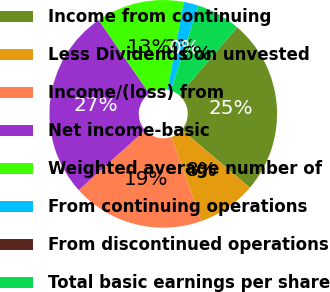Convert chart. <chart><loc_0><loc_0><loc_500><loc_500><pie_chart><fcel>Income from continuing<fcel>Less Dividends on unvested<fcel>Income/(loss) from<fcel>Net income-basic<fcel>Weighted average number of<fcel>From continuing operations<fcel>From discontinued operations<fcel>Total basic earnings per share<nl><fcel>25.0%<fcel>8.33%<fcel>18.75%<fcel>27.08%<fcel>12.5%<fcel>2.08%<fcel>0.0%<fcel>6.25%<nl></chart> 